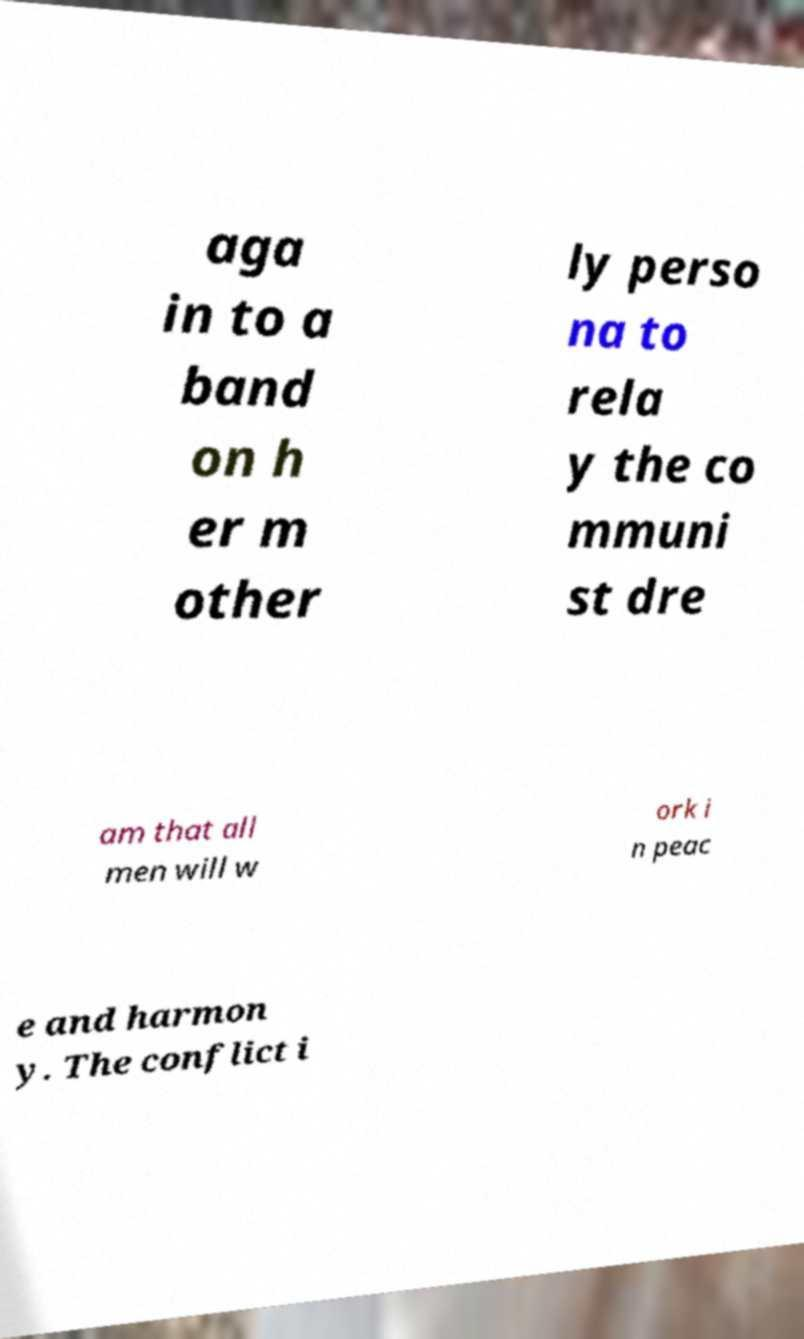Could you extract and type out the text from this image? aga in to a band on h er m other ly perso na to rela y the co mmuni st dre am that all men will w ork i n peac e and harmon y. The conflict i 